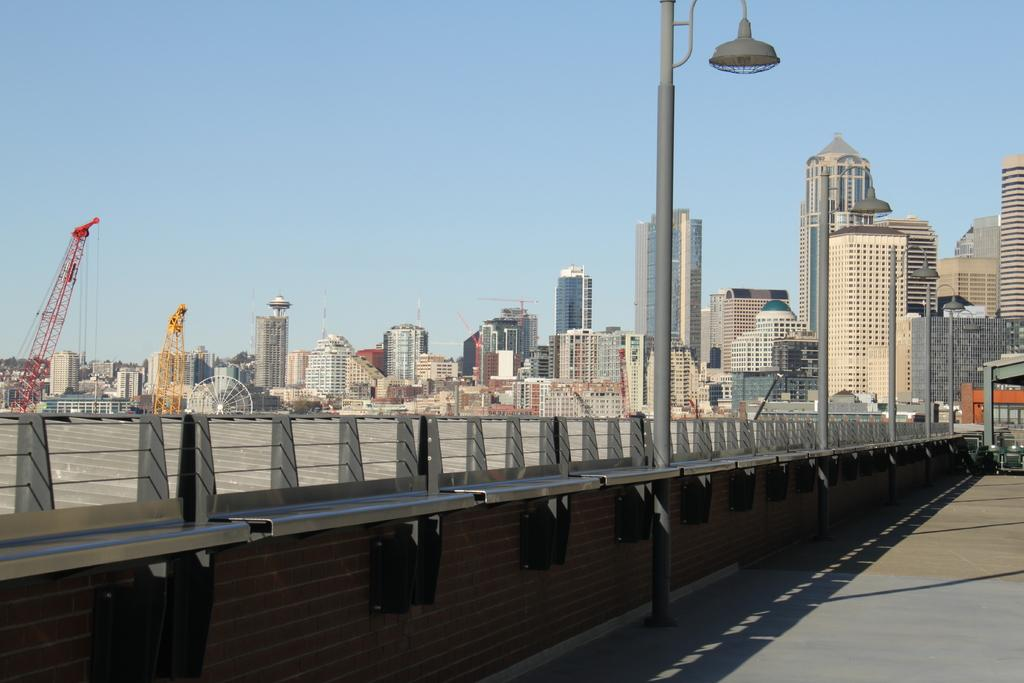What type of structures can be seen in the image? There are many buildings in the image. What are some other objects visible in the image? There are light poles, cranes, a fence, and a road in the image. What is visible in the sky in the image? The sky is visible in the image. Can you see a duck kissing the news in the image? There is no duck, kissing, or news present in the image. 